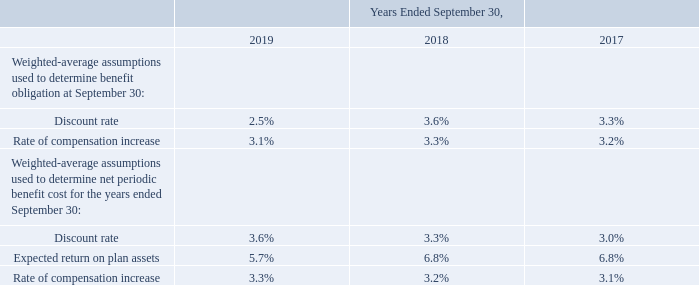The long-term rate of return assumption represents the expected average rate of earnings on the funds invested or to be invested to provide for the benefits included in the benefit obligations. That assumption is determined based on a number of factors, including historical market index returns, the anticipated long-term asset allocation of the plans, historical plan return data, plan expenses, and the potential to outperform market index returns.
We have the responsibility to formulate the investment policies and strategies for the plans’ assets. Our overall policies and strategies include: maintain the highest possible return commensurate with the level of assumed risk, and preserve benefit security for the plans’ participants.
We do not direct the day-to-day operations and selection process of individual securities and investments and, accordingly, we have retained the professional services of investment management organizations to fulfill those tasks. The investment management organizations have investment discretion over the assets placed under their management. We provide each investment manager with specific investment guidelines by asset class.
What does the long-term rate of return assumption represent? The expected average rate of earnings on the funds invested or to be invested to provide for the benefits included in the benefit obligations. How is the long-term rate of return assumption determined? Based on a number of factors, including historical market index returns, the anticipated long-term asset allocation of the plans, historical plan return data, plan expenses, and the potential to outperform market index returns. What are the components under the Weighted-average assumptions used to determine benefit obligation at September 30? Discount rate, rate of compensation increase. For the weighted-average assumptions used to determine benefit obligation at September 30, which year has the largest rate of compensation increase? 3.3%>3.2%>3.1%
Answer: 2018. For the weighted-average assumptions used to determine benefit obligation at September 30, what is the change in the discount rate in 2019 from 2018?
Answer scale should be: percent. 2.5%-3.6%
Answer: -1.1. For the weighted-average assumptions used to determine benefit obligation at September 30, what is the average discount rate across 2017, 2018 and 2019?
Answer scale should be: percent. (2.5%+3.6%+3.3%)/3
Answer: 3.13. 